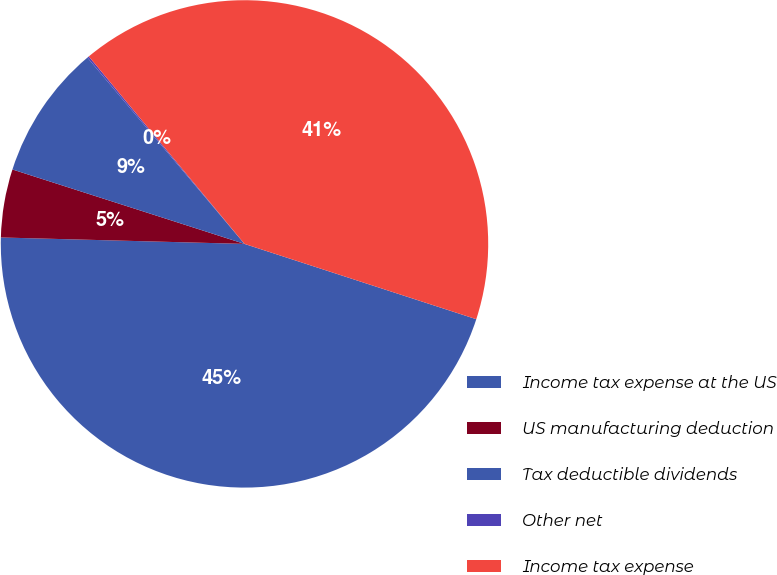<chart> <loc_0><loc_0><loc_500><loc_500><pie_chart><fcel>Income tax expense at the US<fcel>US manufacturing deduction<fcel>Tax deductible dividends<fcel>Other net<fcel>Income tax expense<nl><fcel>45.42%<fcel>4.52%<fcel>8.91%<fcel>0.12%<fcel>41.03%<nl></chart> 